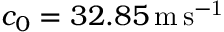<formula> <loc_0><loc_0><loc_500><loc_500>c _ { 0 } = 3 2 . 8 5 \, m \, s ^ { - 1 }</formula> 